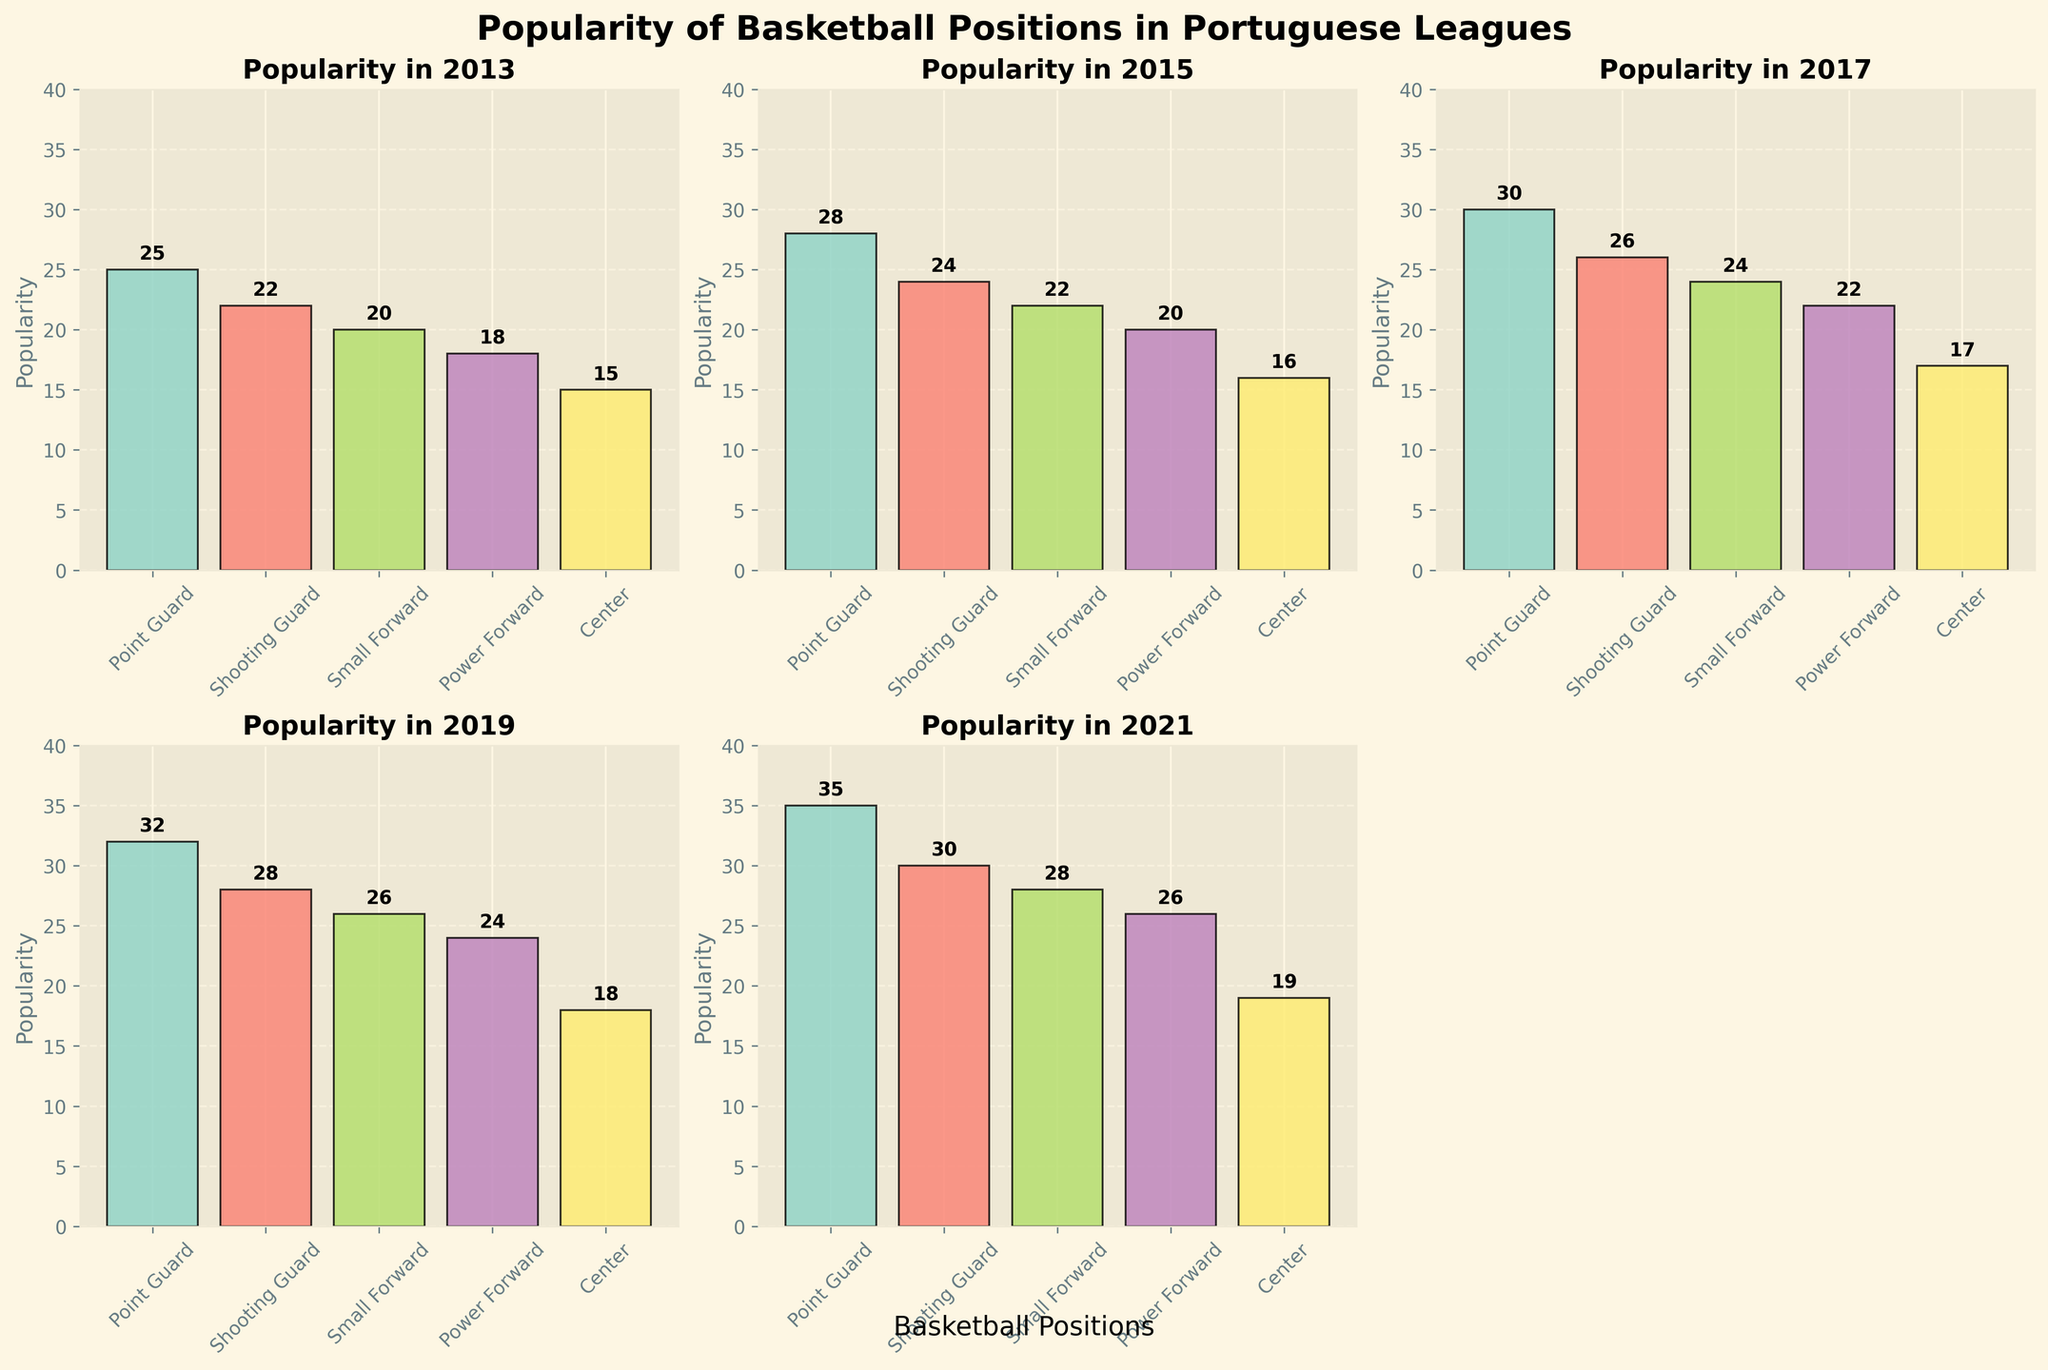What is the title of the figure? The title appears at the top of the figure, providing an overview of the data presented.
Answer: Popularity of Basketball Positions in Portuguese Leagues Which position was the least popular in 2021? By looking at the subplot for 2021, we can identify the position with the lowest bar.
Answer: Center How does the popularity of Shooting Guards compare between 2013 and 2019? Subtract the value for 2013 from the value for 2019 to understand the change. 2019 has 28, and 2013 has 22.
Answer: Increased by 6 Which year showed the highest popularity for Point Guards? By looking at the subplots for each year, observe the height of the bars for Point Guards. The tallest bar indicates the highest popularity.
Answer: 2021 Which positions have shown a consistent increase in popularity over the years? By examining all the subplots, positions with bars that consistently grow taller from left to right across the years are increasing.
Answer: All positions Between Small Forward and Power Forward, which had a higher growth in popularity from 2013 to 2021? Calculate the difference in popularity for both positions between 2013 and 2021, and then compare these values. The difference for Small Forward is 28 - 20 = 8 and for Power Forward is 26 - 18 = 8.
Answer: Both had equal growth What is the median value of popularity for Centers across all years? List the values for Centers over the years: 15, 16, 17, 18, 19, and find the middle value after sorting. Since there are 5 values, the median is the third value in an ordered list.
Answer: 17 In which year was the popularity difference between Point Guard and Power Forward the smallest? Subtract the popularity values of Power Forward from Point Guard for each year and identify the year with the smallest difference. 2013: 7, 2015: 8, 2017: 8, 2019: 8, 2021: 9.
Answer: 2013 Which year had exactly the same popularity gap between Small Forward and Shooting Guard as in 2021? Check the gap for 2021 (30 - 28 = 2) and compare it to the gaps in other years: 2013: 2, 2015: 2, 2017: 2, 2019: 2, 2021: 2.
Answer: All years What trend do you observe for the popularity of Centers from 2013 to 2021? By examining the bars for Centers across all years, note whether they consistently rise, fall, or remain stable. In this case, the bars increase.
Answer: Increasing trend 